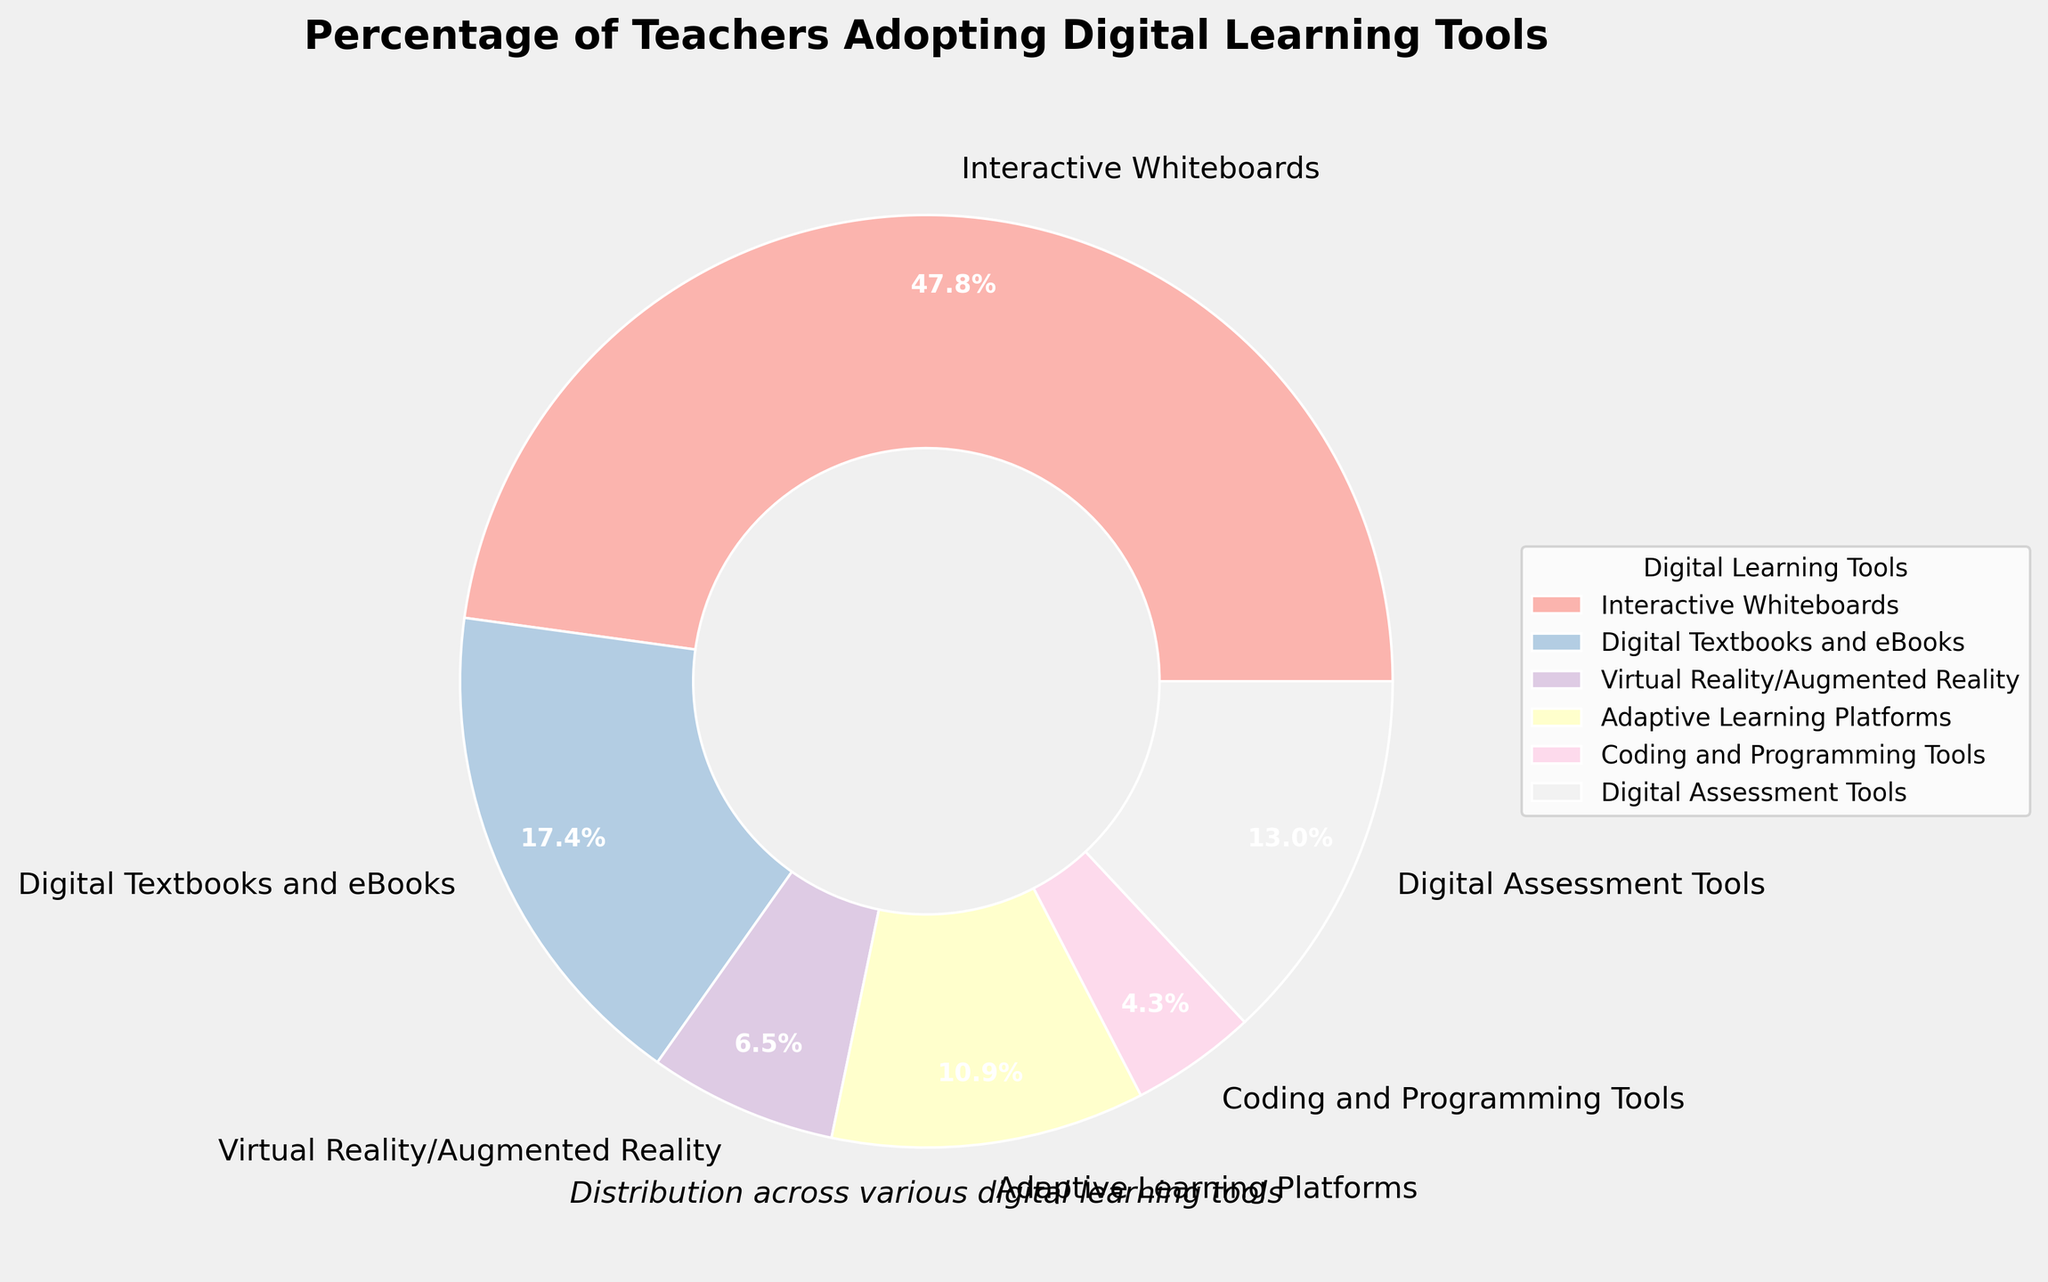What is the percentage of teachers using Interactive Whiteboards? The figure shows a pie chart with various digital learning tools and their adoption percentages by teachers. Specifically, Interactive Whiteboards are listed with a percentage next to them.
Answer: 22% Which digital learning tool has the lowest adoption rate? By observing the pie chart, we can compare the percentages of all digital tools. Coding and Programming Tools have the smallest segment in the pie chart, indicating the lowest percentage.
Answer: Coding and Programming Tools What is the combined percentage of teachers adopting Digital Textbooks and Digital Assessment Tools? To find the combined adoption rate, we add the percentages of Digital Textbooks and Digital Assessment Tools. From the chart, they are 8% and 6%, respectively. So, 8% + 6% = 14%.
Answer: 14% Which digital learning tools have an adoption rate of less than 5%? From the pie chart, we identify the segments with percentages below 5%. These are Virtual Reality/Augmented Reality (3%) and Coding and Programming Tools (2%).
Answer: Virtual Reality/Augmented Reality and Coding and Programming Tools By how much does the adoption rate of Interactive Whiteboards exceed that of Adaptive Learning Platforms? We subtract the percentage of Adaptive Learning Platforms (5%) from the percentage of Interactive Whiteboards (22%). So, 22% - 5% = 17%.
Answer: 17% Arrange the digital learning tools in descending order of adoption rate. By examining the pie chart, we list the digital tools starting from the highest to the lowest percentage: Interactive Whiteboards (22%), Digital Textbooks and eBooks (8%), Digital Assessment Tools (6%), Adaptive Learning Platforms (5%), Virtual Reality/Augmented Reality (3%), and Coding and Programming Tools (2%).
Answer: Interactive Whiteboards, Digital Textbooks and eBooks, Digital Assessment Tools, Adaptive Learning Platforms, Virtual Reality/Augmented Reality, Coding and Programming Tools What is the average adoption rate of all the digital learning tools? To determine the average, sum the percentages of all tools and divide by the number of tools. The sum is 22% + 8% + 3% + 5% + 2% + 6% = 46%. There are 6 tools, so 46% / 6 = 7.67%.
Answer: 7.67% How does the adoption rate of Digital Assessment Tools compare to that of Coding and Programming Tools? Comparing the two percentages from the pie chart, Digital Assessment Tools have a percentage of 6%, whereas Coding and Programming Tools have a percentage of 2%. Therefore, Digital Assessment Tools have a higher adoption rate.
Answer: Digital Assessment Tools have a higher adoption rate 